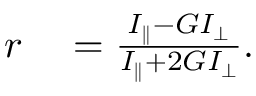Convert formula to latex. <formula><loc_0><loc_0><loc_500><loc_500>\begin{array} { r l } { r } & = \frac { I _ { \| } - G I _ { \perp } } { I _ { \| } + 2 G I _ { \perp } } . } \end{array}</formula> 